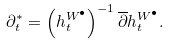Convert formula to latex. <formula><loc_0><loc_0><loc_500><loc_500>\partial ^ { * } _ { t } = \left ( h ^ { W ^ { \bullet } } _ { t } \right ) ^ { - 1 } \overline { \partial } h ^ { W ^ { \bullet } } _ { t } .</formula> 